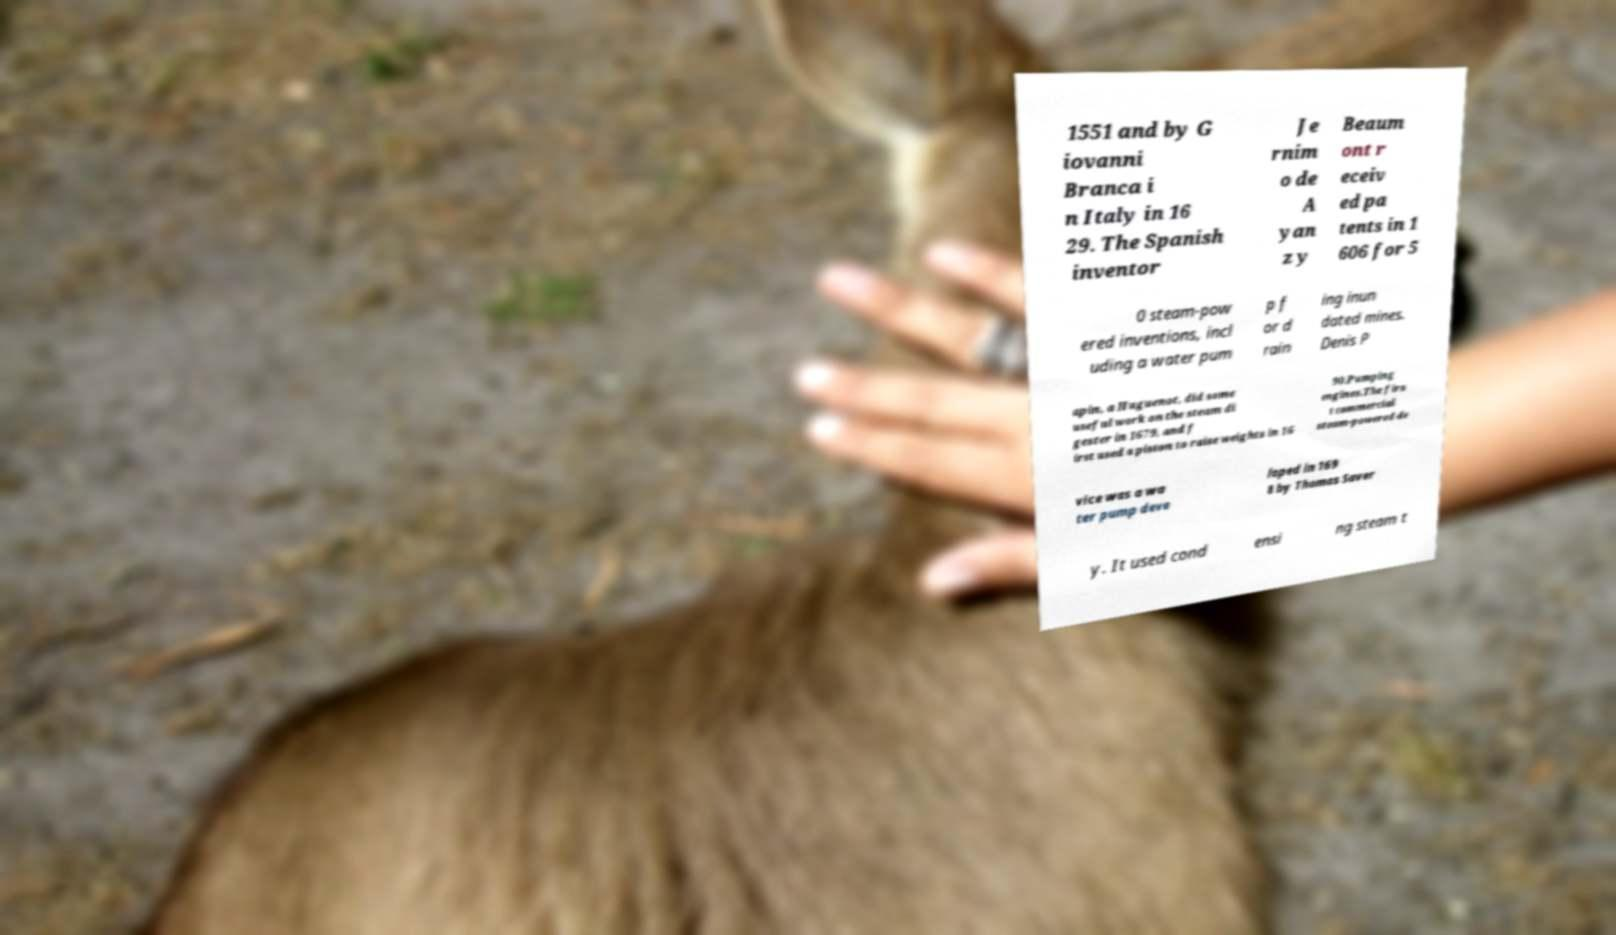What messages or text are displayed in this image? I need them in a readable, typed format. 1551 and by G iovanni Branca i n Italy in 16 29. The Spanish inventor Je rnim o de A yan z y Beaum ont r eceiv ed pa tents in 1 606 for 5 0 steam-pow ered inventions, incl uding a water pum p f or d rain ing inun dated mines. Denis P apin, a Huguenot, did some useful work on the steam di gester in 1679, and f irst used a piston to raise weights in 16 90.Pumping engines.The firs t commercial steam-powered de vice was a wa ter pump deve loped in 169 8 by Thomas Saver y. It used cond ensi ng steam t 